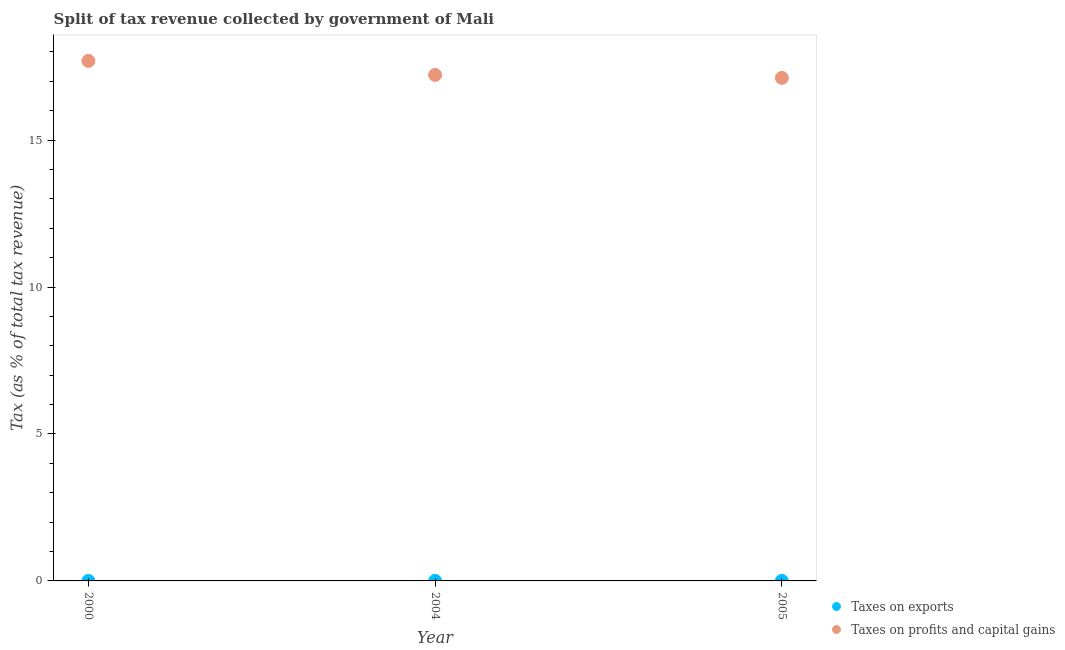How many different coloured dotlines are there?
Offer a very short reply. 2. Is the number of dotlines equal to the number of legend labels?
Your answer should be compact. Yes. What is the percentage of revenue obtained from taxes on profits and capital gains in 2004?
Your answer should be compact. 17.22. Across all years, what is the maximum percentage of revenue obtained from taxes on exports?
Keep it short and to the point. 0. Across all years, what is the minimum percentage of revenue obtained from taxes on exports?
Provide a short and direct response. 0. In which year was the percentage of revenue obtained from taxes on exports minimum?
Offer a very short reply. 2000. What is the total percentage of revenue obtained from taxes on profits and capital gains in the graph?
Offer a very short reply. 52.03. What is the difference between the percentage of revenue obtained from taxes on profits and capital gains in 2000 and that in 2005?
Your answer should be very brief. 0.58. What is the difference between the percentage of revenue obtained from taxes on exports in 2000 and the percentage of revenue obtained from taxes on profits and capital gains in 2005?
Provide a succinct answer. -17.12. What is the average percentage of revenue obtained from taxes on exports per year?
Ensure brevity in your answer.  0. In the year 2004, what is the difference between the percentage of revenue obtained from taxes on exports and percentage of revenue obtained from taxes on profits and capital gains?
Provide a short and direct response. -17.22. In how many years, is the percentage of revenue obtained from taxes on exports greater than 15 %?
Your response must be concise. 0. What is the ratio of the percentage of revenue obtained from taxes on exports in 2000 to that in 2005?
Your response must be concise. 0.07. Is the percentage of revenue obtained from taxes on profits and capital gains in 2000 less than that in 2005?
Ensure brevity in your answer.  No. What is the difference between the highest and the second highest percentage of revenue obtained from taxes on exports?
Your response must be concise. 0. What is the difference between the highest and the lowest percentage of revenue obtained from taxes on profits and capital gains?
Offer a terse response. 0.58. In how many years, is the percentage of revenue obtained from taxes on exports greater than the average percentage of revenue obtained from taxes on exports taken over all years?
Offer a terse response. 2. Is the percentage of revenue obtained from taxes on exports strictly greater than the percentage of revenue obtained from taxes on profits and capital gains over the years?
Your response must be concise. No. Is the percentage of revenue obtained from taxes on profits and capital gains strictly less than the percentage of revenue obtained from taxes on exports over the years?
Offer a very short reply. No. How many dotlines are there?
Make the answer very short. 2. How many years are there in the graph?
Offer a very short reply. 3. What is the difference between two consecutive major ticks on the Y-axis?
Your response must be concise. 5. Does the graph contain grids?
Make the answer very short. No. Where does the legend appear in the graph?
Ensure brevity in your answer.  Bottom right. What is the title of the graph?
Provide a succinct answer. Split of tax revenue collected by government of Mali. What is the label or title of the X-axis?
Provide a succinct answer. Year. What is the label or title of the Y-axis?
Your response must be concise. Tax (as % of total tax revenue). What is the Tax (as % of total tax revenue) of Taxes on exports in 2000?
Provide a short and direct response. 0. What is the Tax (as % of total tax revenue) in Taxes on profits and capital gains in 2000?
Your response must be concise. 17.7. What is the Tax (as % of total tax revenue) in Taxes on exports in 2004?
Give a very brief answer. 0. What is the Tax (as % of total tax revenue) in Taxes on profits and capital gains in 2004?
Your answer should be very brief. 17.22. What is the Tax (as % of total tax revenue) of Taxes on exports in 2005?
Your answer should be compact. 0. What is the Tax (as % of total tax revenue) in Taxes on profits and capital gains in 2005?
Provide a short and direct response. 17.12. Across all years, what is the maximum Tax (as % of total tax revenue) of Taxes on exports?
Your answer should be very brief. 0. Across all years, what is the maximum Tax (as % of total tax revenue) in Taxes on profits and capital gains?
Your answer should be compact. 17.7. Across all years, what is the minimum Tax (as % of total tax revenue) of Taxes on exports?
Your answer should be very brief. 0. Across all years, what is the minimum Tax (as % of total tax revenue) in Taxes on profits and capital gains?
Offer a terse response. 17.12. What is the total Tax (as % of total tax revenue) in Taxes on exports in the graph?
Your answer should be compact. 0. What is the total Tax (as % of total tax revenue) in Taxes on profits and capital gains in the graph?
Offer a terse response. 52.03. What is the difference between the Tax (as % of total tax revenue) of Taxes on exports in 2000 and that in 2004?
Offer a very short reply. -0. What is the difference between the Tax (as % of total tax revenue) in Taxes on profits and capital gains in 2000 and that in 2004?
Give a very brief answer. 0.48. What is the difference between the Tax (as % of total tax revenue) of Taxes on exports in 2000 and that in 2005?
Offer a terse response. -0. What is the difference between the Tax (as % of total tax revenue) of Taxes on profits and capital gains in 2000 and that in 2005?
Your response must be concise. 0.58. What is the difference between the Tax (as % of total tax revenue) of Taxes on exports in 2004 and that in 2005?
Your response must be concise. -0. What is the difference between the Tax (as % of total tax revenue) in Taxes on profits and capital gains in 2004 and that in 2005?
Offer a terse response. 0.1. What is the difference between the Tax (as % of total tax revenue) in Taxes on exports in 2000 and the Tax (as % of total tax revenue) in Taxes on profits and capital gains in 2004?
Offer a very short reply. -17.22. What is the difference between the Tax (as % of total tax revenue) in Taxes on exports in 2000 and the Tax (as % of total tax revenue) in Taxes on profits and capital gains in 2005?
Your response must be concise. -17.12. What is the difference between the Tax (as % of total tax revenue) of Taxes on exports in 2004 and the Tax (as % of total tax revenue) of Taxes on profits and capital gains in 2005?
Keep it short and to the point. -17.12. What is the average Tax (as % of total tax revenue) in Taxes on exports per year?
Provide a short and direct response. 0. What is the average Tax (as % of total tax revenue) of Taxes on profits and capital gains per year?
Give a very brief answer. 17.34. In the year 2000, what is the difference between the Tax (as % of total tax revenue) of Taxes on exports and Tax (as % of total tax revenue) of Taxes on profits and capital gains?
Your answer should be compact. -17.7. In the year 2004, what is the difference between the Tax (as % of total tax revenue) of Taxes on exports and Tax (as % of total tax revenue) of Taxes on profits and capital gains?
Provide a succinct answer. -17.22. In the year 2005, what is the difference between the Tax (as % of total tax revenue) in Taxes on exports and Tax (as % of total tax revenue) in Taxes on profits and capital gains?
Give a very brief answer. -17.12. What is the ratio of the Tax (as % of total tax revenue) in Taxes on exports in 2000 to that in 2004?
Offer a very short reply. 0.11. What is the ratio of the Tax (as % of total tax revenue) in Taxes on profits and capital gains in 2000 to that in 2004?
Your answer should be compact. 1.03. What is the ratio of the Tax (as % of total tax revenue) of Taxes on exports in 2000 to that in 2005?
Your answer should be compact. 0.07. What is the ratio of the Tax (as % of total tax revenue) of Taxes on profits and capital gains in 2000 to that in 2005?
Your response must be concise. 1.03. What is the ratio of the Tax (as % of total tax revenue) of Taxes on exports in 2004 to that in 2005?
Offer a very short reply. 0.58. What is the ratio of the Tax (as % of total tax revenue) in Taxes on profits and capital gains in 2004 to that in 2005?
Provide a short and direct response. 1.01. What is the difference between the highest and the second highest Tax (as % of total tax revenue) of Taxes on exports?
Offer a terse response. 0. What is the difference between the highest and the second highest Tax (as % of total tax revenue) of Taxes on profits and capital gains?
Your answer should be compact. 0.48. What is the difference between the highest and the lowest Tax (as % of total tax revenue) in Taxes on exports?
Keep it short and to the point. 0. What is the difference between the highest and the lowest Tax (as % of total tax revenue) in Taxes on profits and capital gains?
Your answer should be very brief. 0.58. 